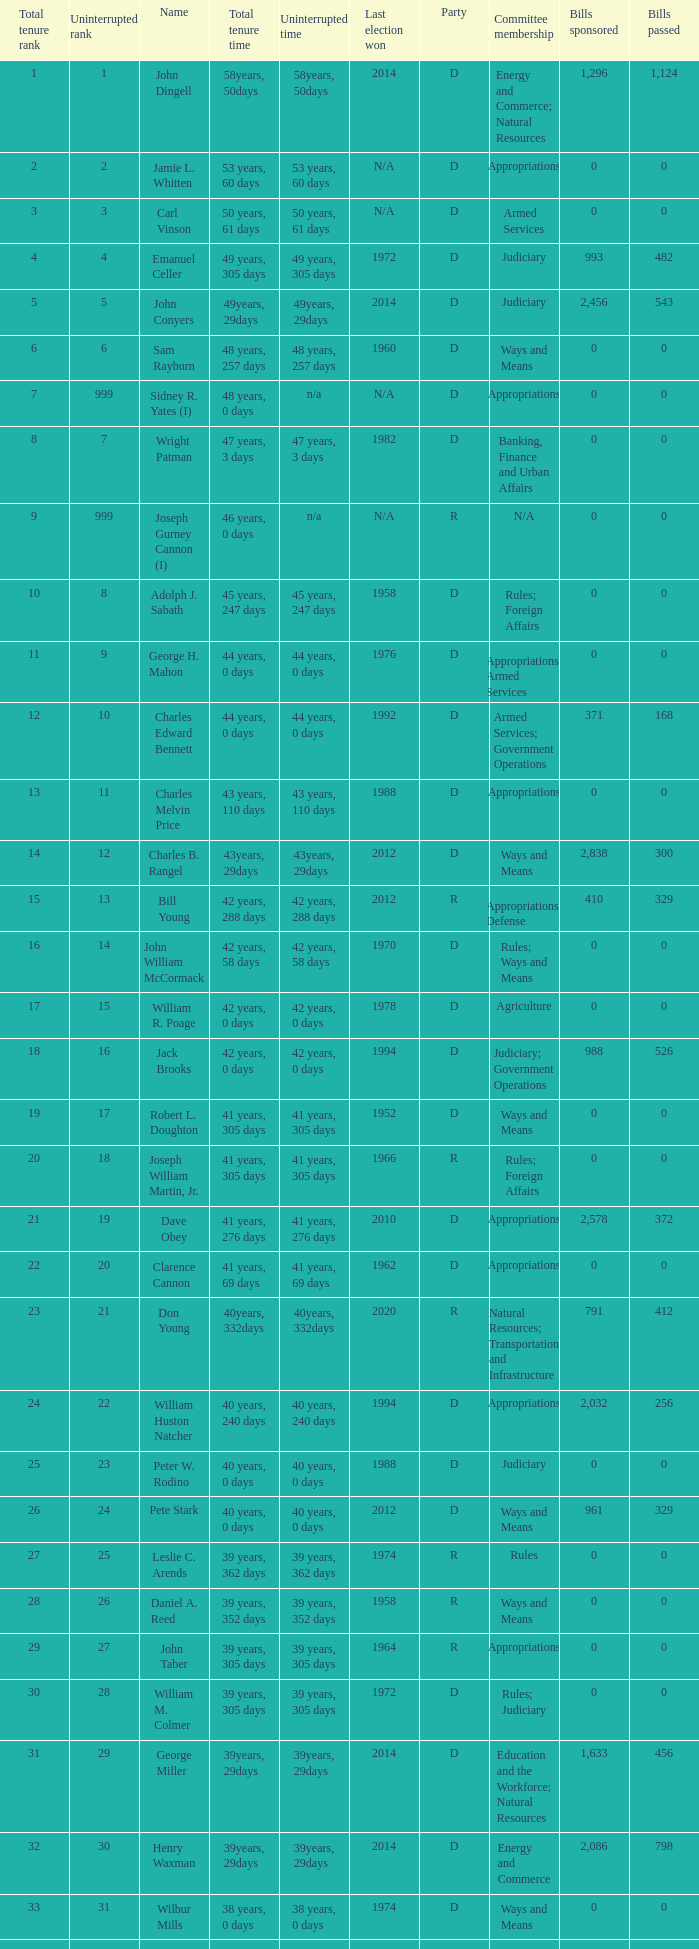How many uninterrupted ranks does john dingell have? 1.0. 